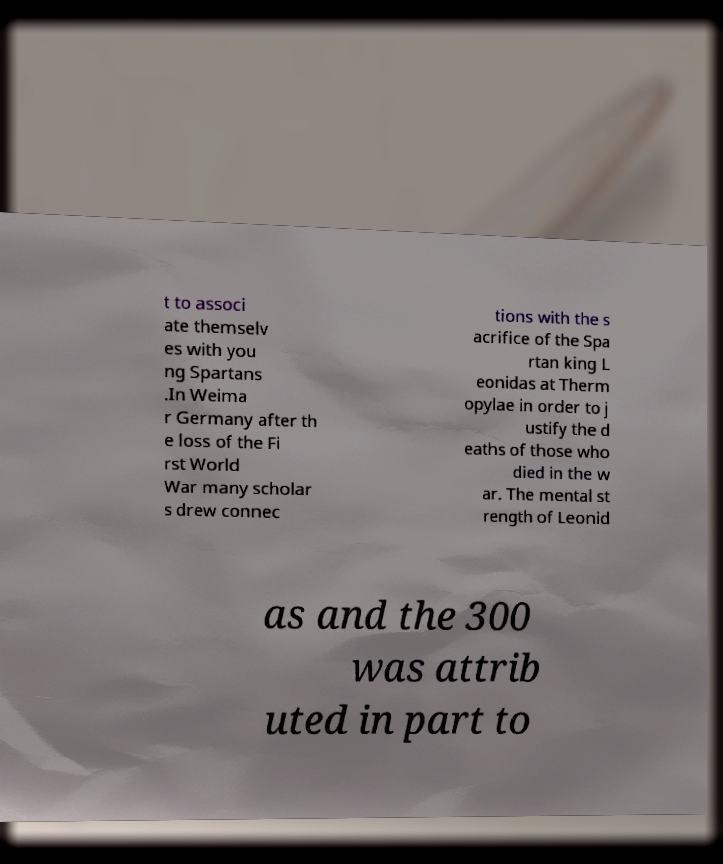Can you read and provide the text displayed in the image?This photo seems to have some interesting text. Can you extract and type it out for me? t to associ ate themselv es with you ng Spartans .In Weima r Germany after th e loss of the Fi rst World War many scholar s drew connec tions with the s acrifice of the Spa rtan king L eonidas at Therm opylae in order to j ustify the d eaths of those who died in the w ar. The mental st rength of Leonid as and the 300 was attrib uted in part to 